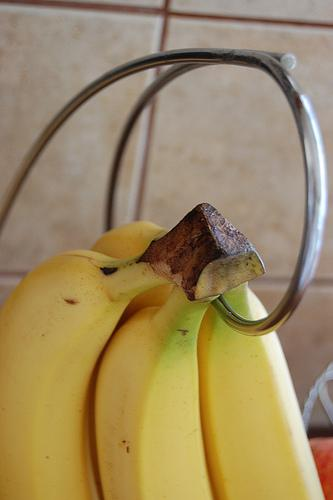Question: where was the photo taken?
Choices:
A. Outside.
B. Bedroom.
C. Bathroom.
D. Kitchen.
Answer with the letter. Answer: D Question: what color are the bananas?
Choices:
A. Brown.
B. Black.
C. Yellow.
D. Gray.
Answer with the letter. Answer: C Question: how many bananas are there?
Choices:
A. Five.
B. Six.
C. Four.
D. Two.
Answer with the letter. Answer: C Question: what fruit is in the photo?
Choices:
A. Oranges.
B. Apples.
C. Grapes.
D. Bananas.
Answer with the letter. Answer: D Question: how many banana holders are there?
Choices:
A. Two.
B. Three.
C. SIx.
D. One.
Answer with the letter. Answer: D 